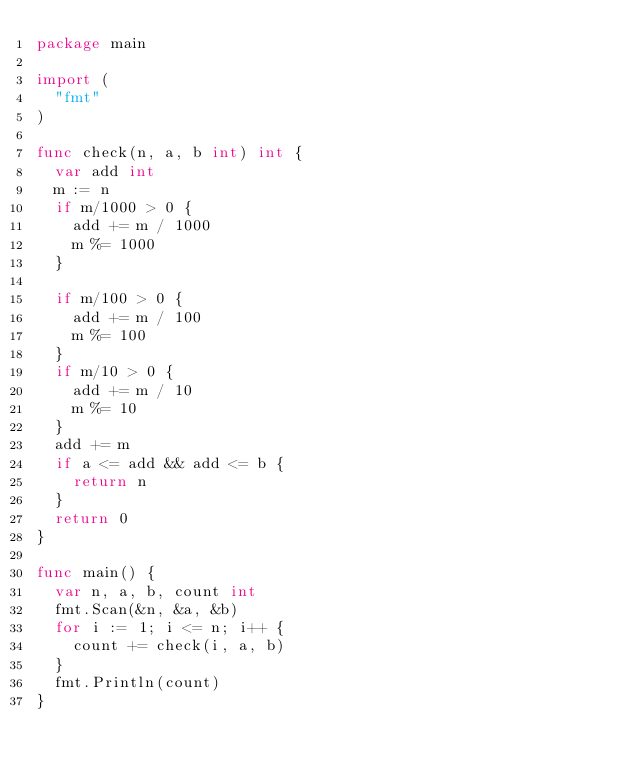<code> <loc_0><loc_0><loc_500><loc_500><_Go_>package main

import (
  "fmt"
)

func check(n, a, b int) int {
  var add int
  m := n
  if m/1000 > 0 {
    add += m / 1000
    m %= 1000
  }

  if m/100 > 0 {
    add += m / 100
    m %= 100
  }
  if m/10 > 0 {
    add += m / 10
    m %= 10
  }
  add += m
  if a <= add && add <= b {
    return n
  }
  return 0
}

func main() {
  var n, a, b, count int
  fmt.Scan(&n, &a, &b)
  for i := 1; i <= n; i++ {
    count += check(i, a, b)
  }
  fmt.Println(count)
}</code> 